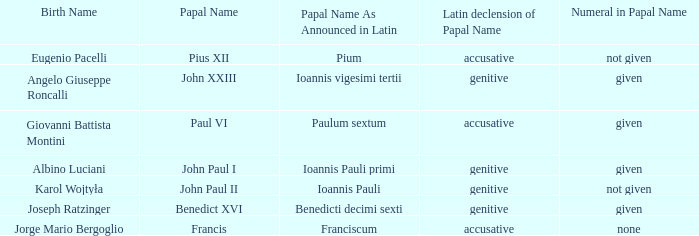What figure is involved for the pope possessing the latin papal name of ioannis pauli? Not given. 